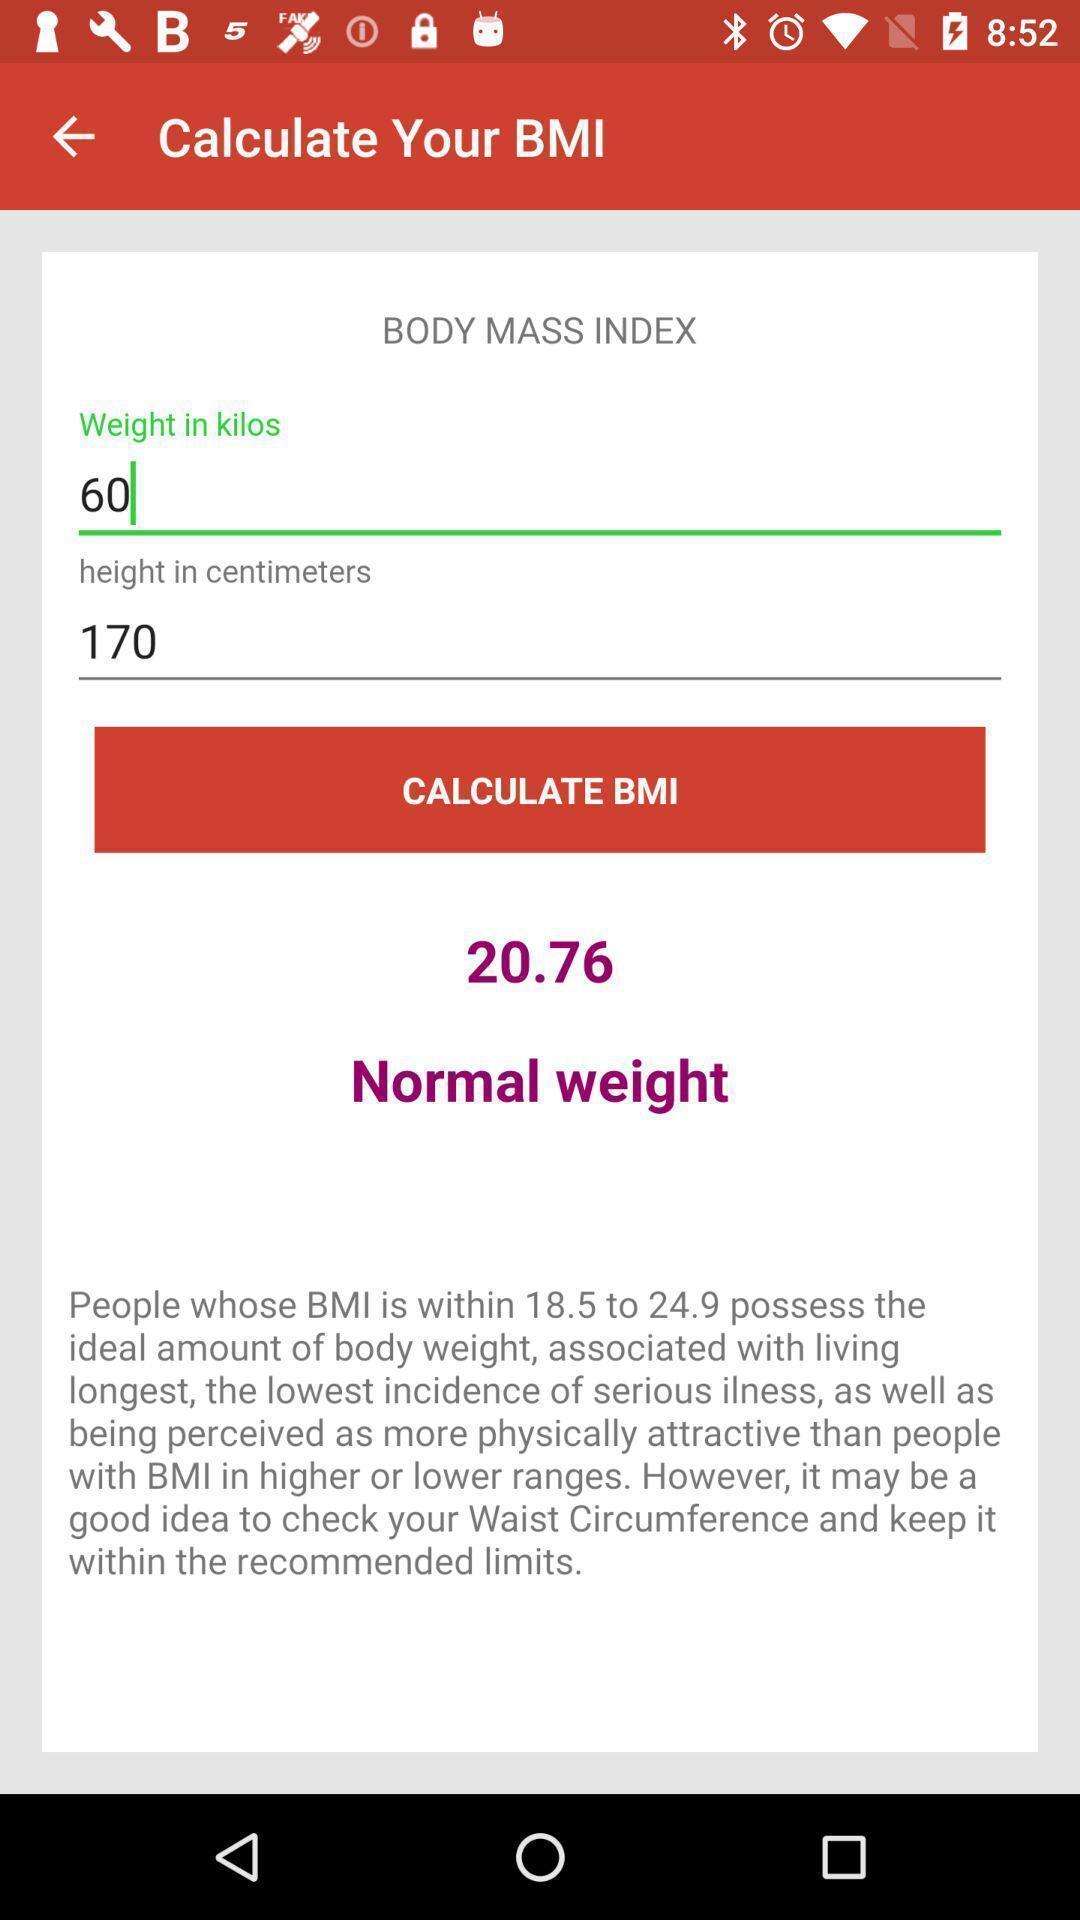Describe this image in words. Page to calculate body weight in the fitness app. 